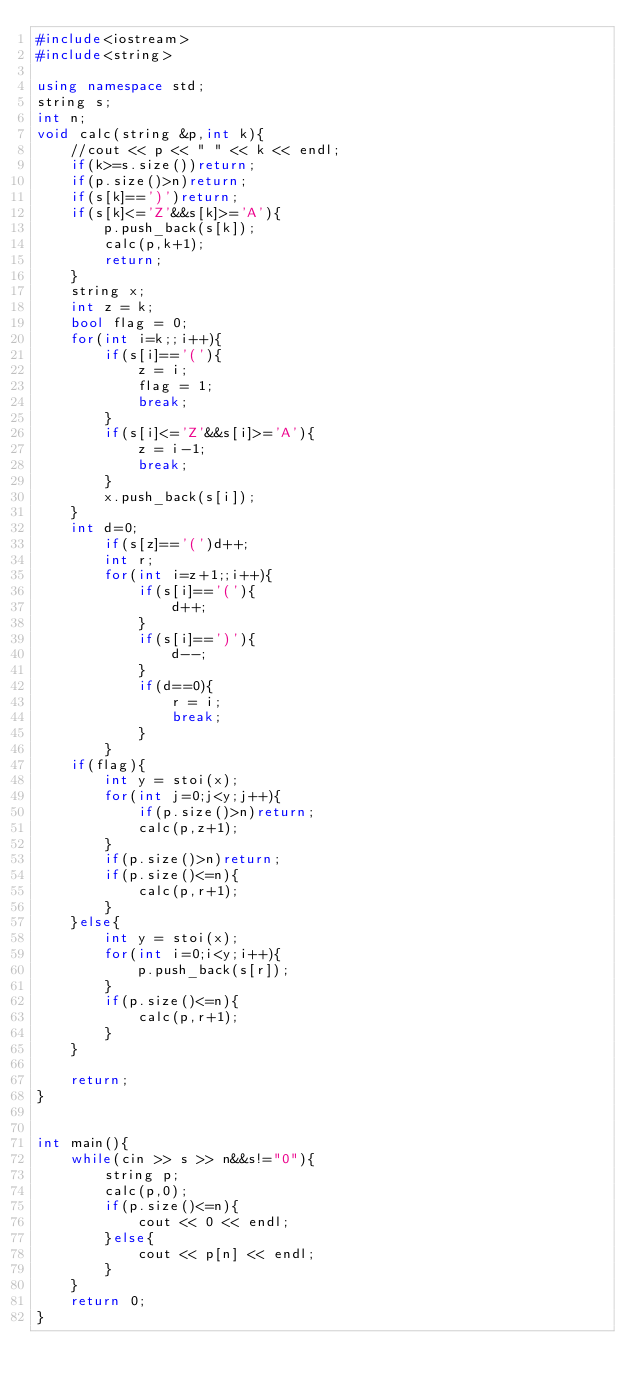Convert code to text. <code><loc_0><loc_0><loc_500><loc_500><_C++_>#include<iostream>
#include<string>

using namespace std;
string s;
int n;
void calc(string &p,int k){
    //cout << p << " " << k << endl;
    if(k>=s.size())return;
    if(p.size()>n)return;
    if(s[k]==')')return;
    if(s[k]<='Z'&&s[k]>='A'){
        p.push_back(s[k]);
        calc(p,k+1);
        return;
    }
    string x;
    int z = k;
    bool flag = 0;
    for(int i=k;;i++){
        if(s[i]=='('){
            z = i;
            flag = 1;
            break;
        }
        if(s[i]<='Z'&&s[i]>='A'){
            z = i-1;
            break;
        }
        x.push_back(s[i]);
    }
    int d=0;
        if(s[z]=='(')d++;
        int r;
        for(int i=z+1;;i++){
            if(s[i]=='('){
                d++;
            }
            if(s[i]==')'){
                d--;
            }
            if(d==0){
                r = i;  
                break;
            }
        }
    if(flag){
        int y = stoi(x);
        for(int j=0;j<y;j++){
            if(p.size()>n)return;
            calc(p,z+1);
        }
        if(p.size()>n)return;
        if(p.size()<=n){
            calc(p,r+1);
        }
    }else{
        int y = stoi(x);
        for(int i=0;i<y;i++){
            p.push_back(s[r]);
        }
        if(p.size()<=n){
            calc(p,r+1);
        }
    }
   
    return;
}


int main(){   
    while(cin >> s >> n&&s!="0"){
        string p;
        calc(p,0);
        if(p.size()<=n){
            cout << 0 << endl;
        }else{
            cout << p[n] << endl;
        }
    }
    return 0;
}
</code> 